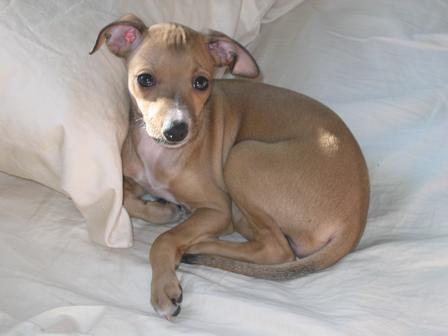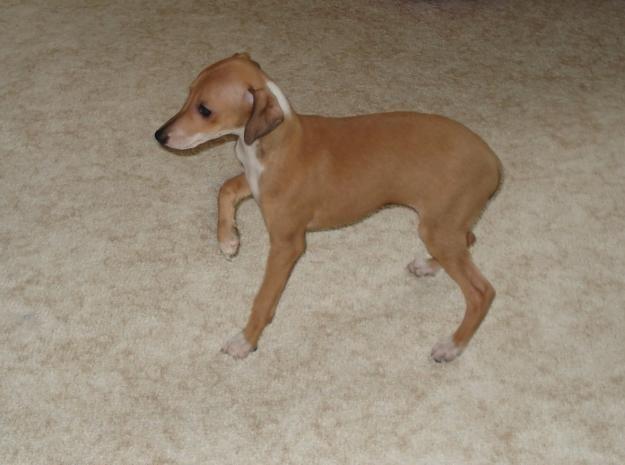The first image is the image on the left, the second image is the image on the right. For the images shown, is this caption "Each image shows exactly one non-standing hound, and the combined images show at least one hound reclining with front paws extended in front of its body." true? Answer yes or no. No. The first image is the image on the left, the second image is the image on the right. Given the left and right images, does the statement "In one of the images the dog is on a tile floor." hold true? Answer yes or no. No. 